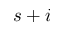<formula> <loc_0><loc_0><loc_500><loc_500>s + i</formula> 